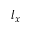Convert formula to latex. <formula><loc_0><loc_0><loc_500><loc_500>l _ { x }</formula> 